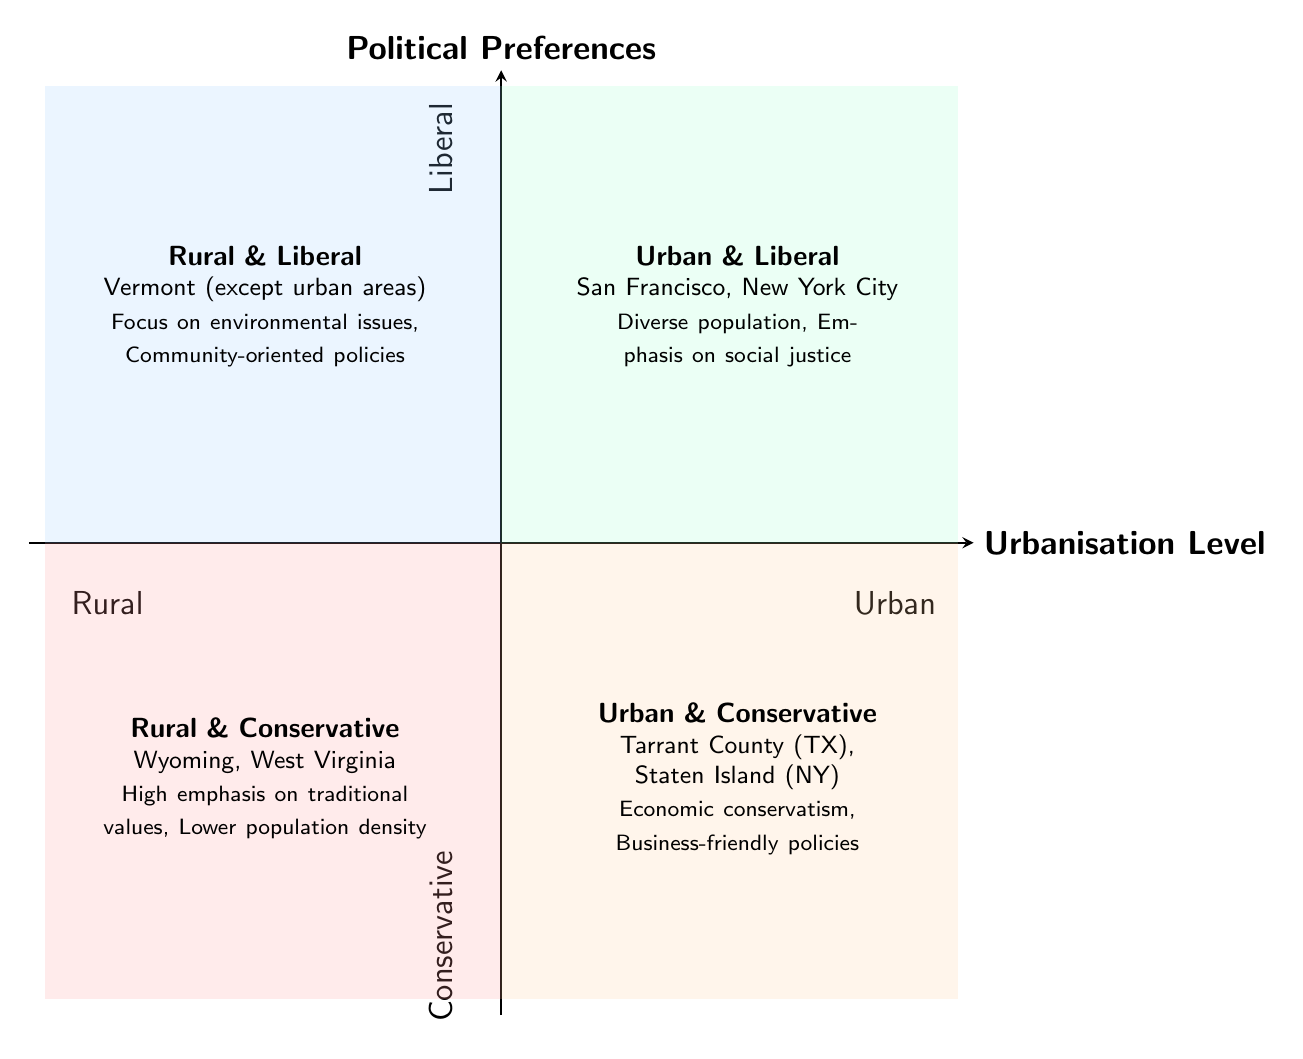What are two examples of areas in the Rural & Conservative quadrant? The Rural & Conservative quadrant is represented by the label and description in the lower-left section of the diagram. It specifically mentions Wyoming and West Virginia as examples.
Answer: Wyoming, West Virginia Which quadrant is associated with a focus on environmental issues? The Rural & Liberal quadrant, positioned in the upper-left section of the diagram, is highlighted for having characteristics related to environmental issues, specifically mentioning Vermont as an example.
Answer: Rural & Liberal What is the political preference of the Urban & Conservative quadrant? The Urban & Conservative quadrant is located in the lower-right section of the diagram and is characterized by its political preference being labeled as Conservative, according to the quadrant's vertical position.
Answer: Conservative Name one characteristic of the Urban & Liberal quadrant. In the Urban & Liberal quadrant, identified in the upper-right section of the chart, one characteristic listed is "Emphasis on social justice," indicating a progressive value system prevalent in metropolitan areas.
Answer: Emphasis on social justice How many quadrants are there in the diagram? The diagram consists of four quadrants: Rural & Conservative, Urban & Conservative, Rural & Liberal, and Urban & Liberal, effectively covering different voter demographics.
Answer: Four quadrants What types of policies are supported in the Rural & Conservative quadrant? The chart states that in the Rural & Conservative quadrant, characteristics include a "High emphasis on traditional values" and "Strong support for agricultural policies," which outline the policies supported.
Answer: Agricultural policies Which quadrant represents a diverse population? The Urban & Liberal quadrant is indicated to represent a diverse population according to the information directly mentioned in its description, suggesting a mix of various demographic backgrounds in urban settings.
Answer: Urban & Liberal What is the relationship between urbanisation level and political preferences in the quadrants? The relationship is defined by the layout of the quadrants: as one moves from the lower-left (Rural & Conservative) to the upper-right (Urban & Liberal), there is a transition from Conservative to Liberal preferences alongside increasing urbanisation.
Answer: Transition from Conservative to Liberal What is a feature of Urban & Conservative areas? The Urban & Conservative area emphasizes "Economic conservatism," a direct characteristic listed under this quadrant, illustrating its political stance despite being in urban locations.
Answer: Economic conservatism 